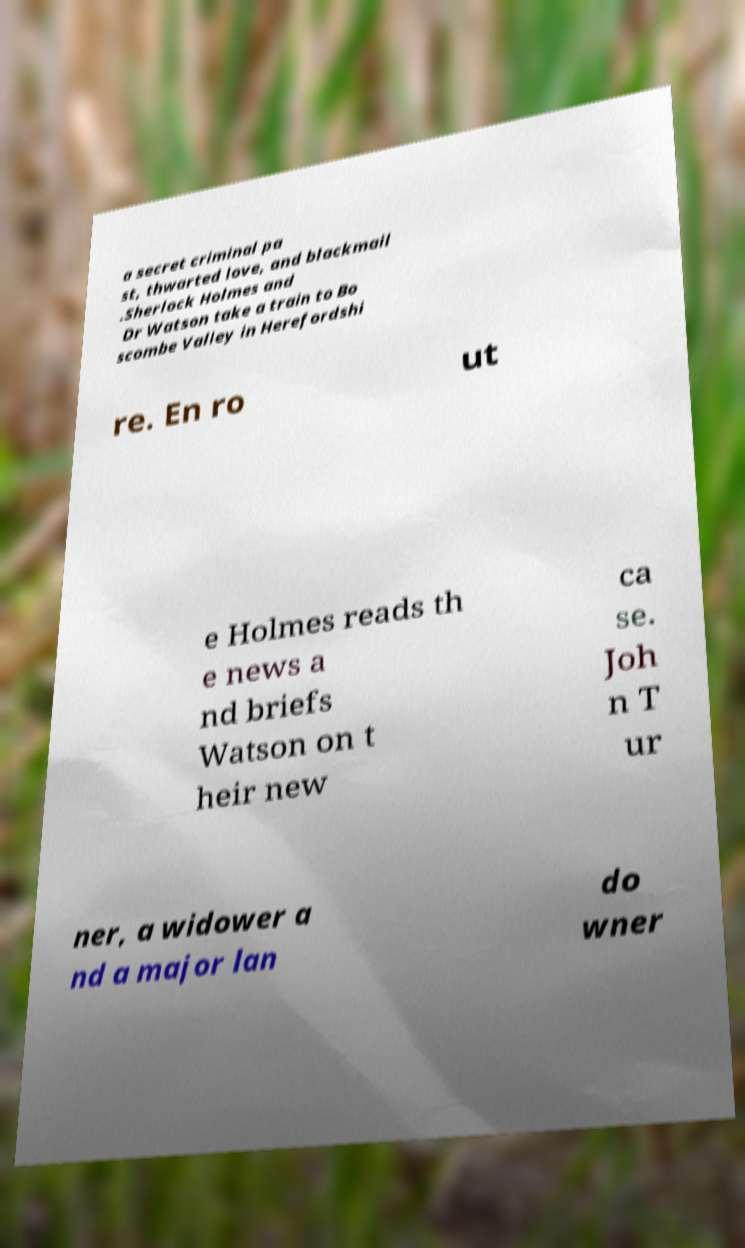Could you extract and type out the text from this image? a secret criminal pa st, thwarted love, and blackmail .Sherlock Holmes and Dr Watson take a train to Bo scombe Valley in Herefordshi re. En ro ut e Holmes reads th e news a nd briefs Watson on t heir new ca se. Joh n T ur ner, a widower a nd a major lan do wner 